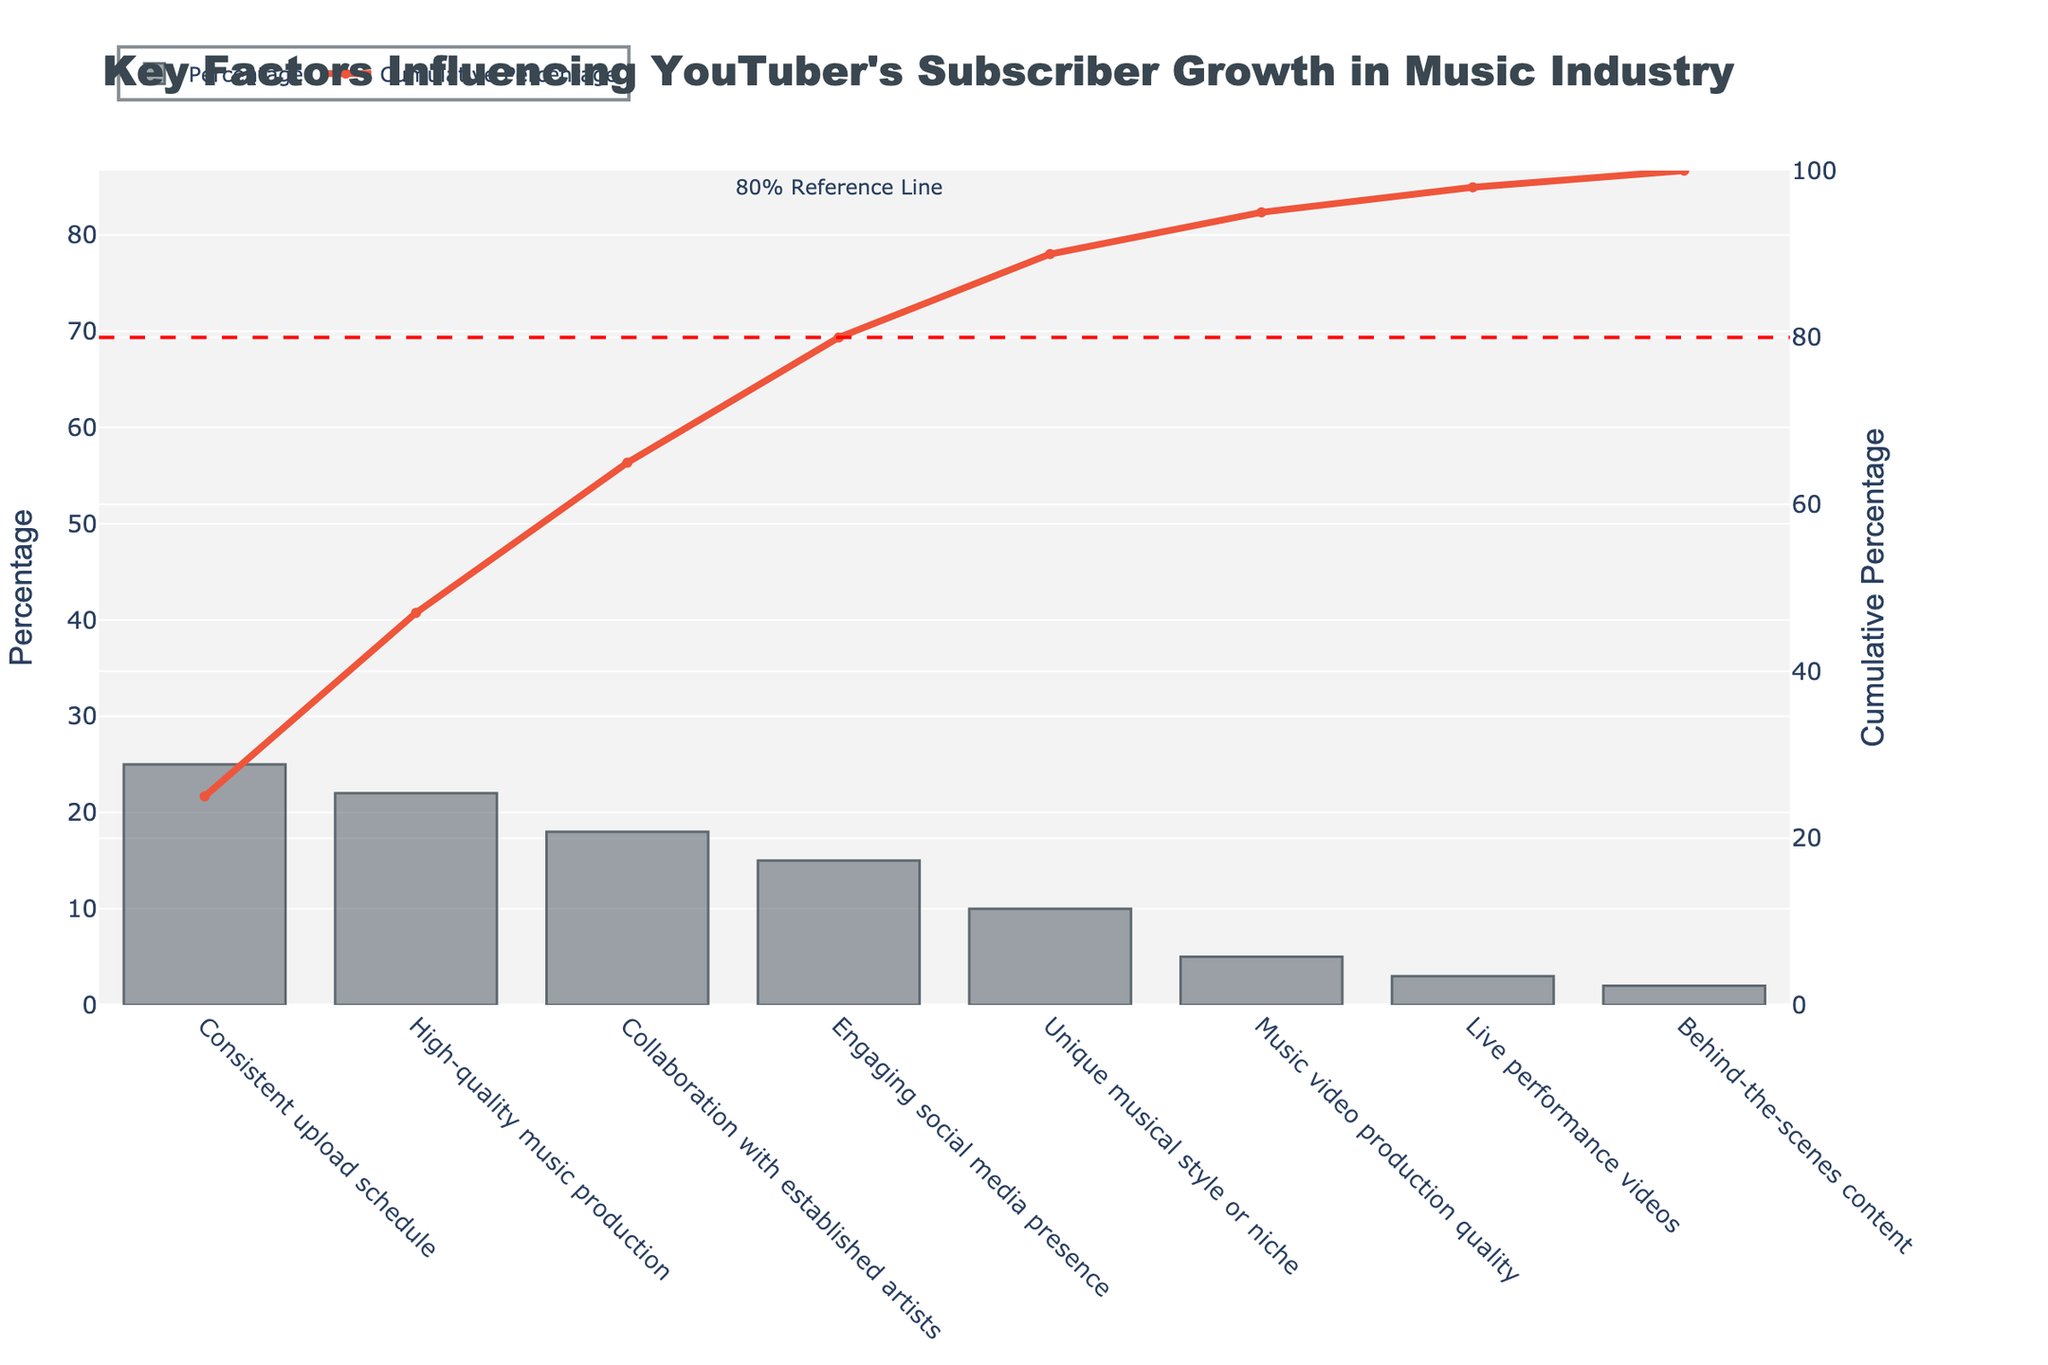What is the percentage contribution of 'High-quality music production'? Look at the bar for 'High-quality music production' on the x-axis and observe its height on the y-axis, which indicates its contribution in percentage.
Answer: 22% What is the cumulative percentage after considering the top three factors? Sum the percentages of 'Consistent upload schedule', 'High-quality music production', and 'Collaboration with established artists', which are 25%, 22%, and 18% respectively, or note the point on the cumulative line graph after three factors.
Answer: 65% Which factor has the smallest contribution to subscriber growth and what is its percentage? Identify the shortest bar on the bar chart and read its associated percentage on the y-axis.
Answer: Behind-the-scenes content, 2% How many factors contribute at least 10% each to subscriber growth? Count the number of bars whose heights reach or exceed the 10% line on the y-axis.
Answer: 5 Which factor does the Pareto chart suggest focusing on first to achieve significant subscriber growth? Identify the tallest bar since it indicates the highest individual contribution to growth.
Answer: Consistent upload schedule What is the combined contribution of 'Live performance videos' and 'Behind-the-scenes content'? Add their respective percentages: 3% for 'Live performance videos' and 2% for 'Behind-the-scenes content'.
Answer: 5% Between 'Collaboration with established artists' and 'Engaging social media presence', which one has a higher contribution? Compare the heights of the bars for these two factors on the y-axis.
Answer: Collaboration with established artists What does the red dashed line at 80% indicate in the context of this Pareto chart? It marks the cumulative percentage at which 80% of the contributions come from the most critical factors, helping identify the "vital few" from the "trivial many."
Answer: 80% threshold How much more does 'Engaging social media presence' contribute compared to 'Music video production quality'? Subtract the percentage of 'Music video production quality' from the percentage of 'Engaging social media presence': 15% - 5%.
Answer: 10% If you were to consider only factors contributing cumulatively to 50%, how many factors would you include? Add the percentages of the top factors until the sum reaches or exceeds 50%. 'Consistent upload schedule' (25%) and 'High-quality music production' (22%) total 47%. Including 'Collaboration with established artists' (18%) brings the cumulative to 65%, but only two factors together reach close to 50%.
Answer: 2 